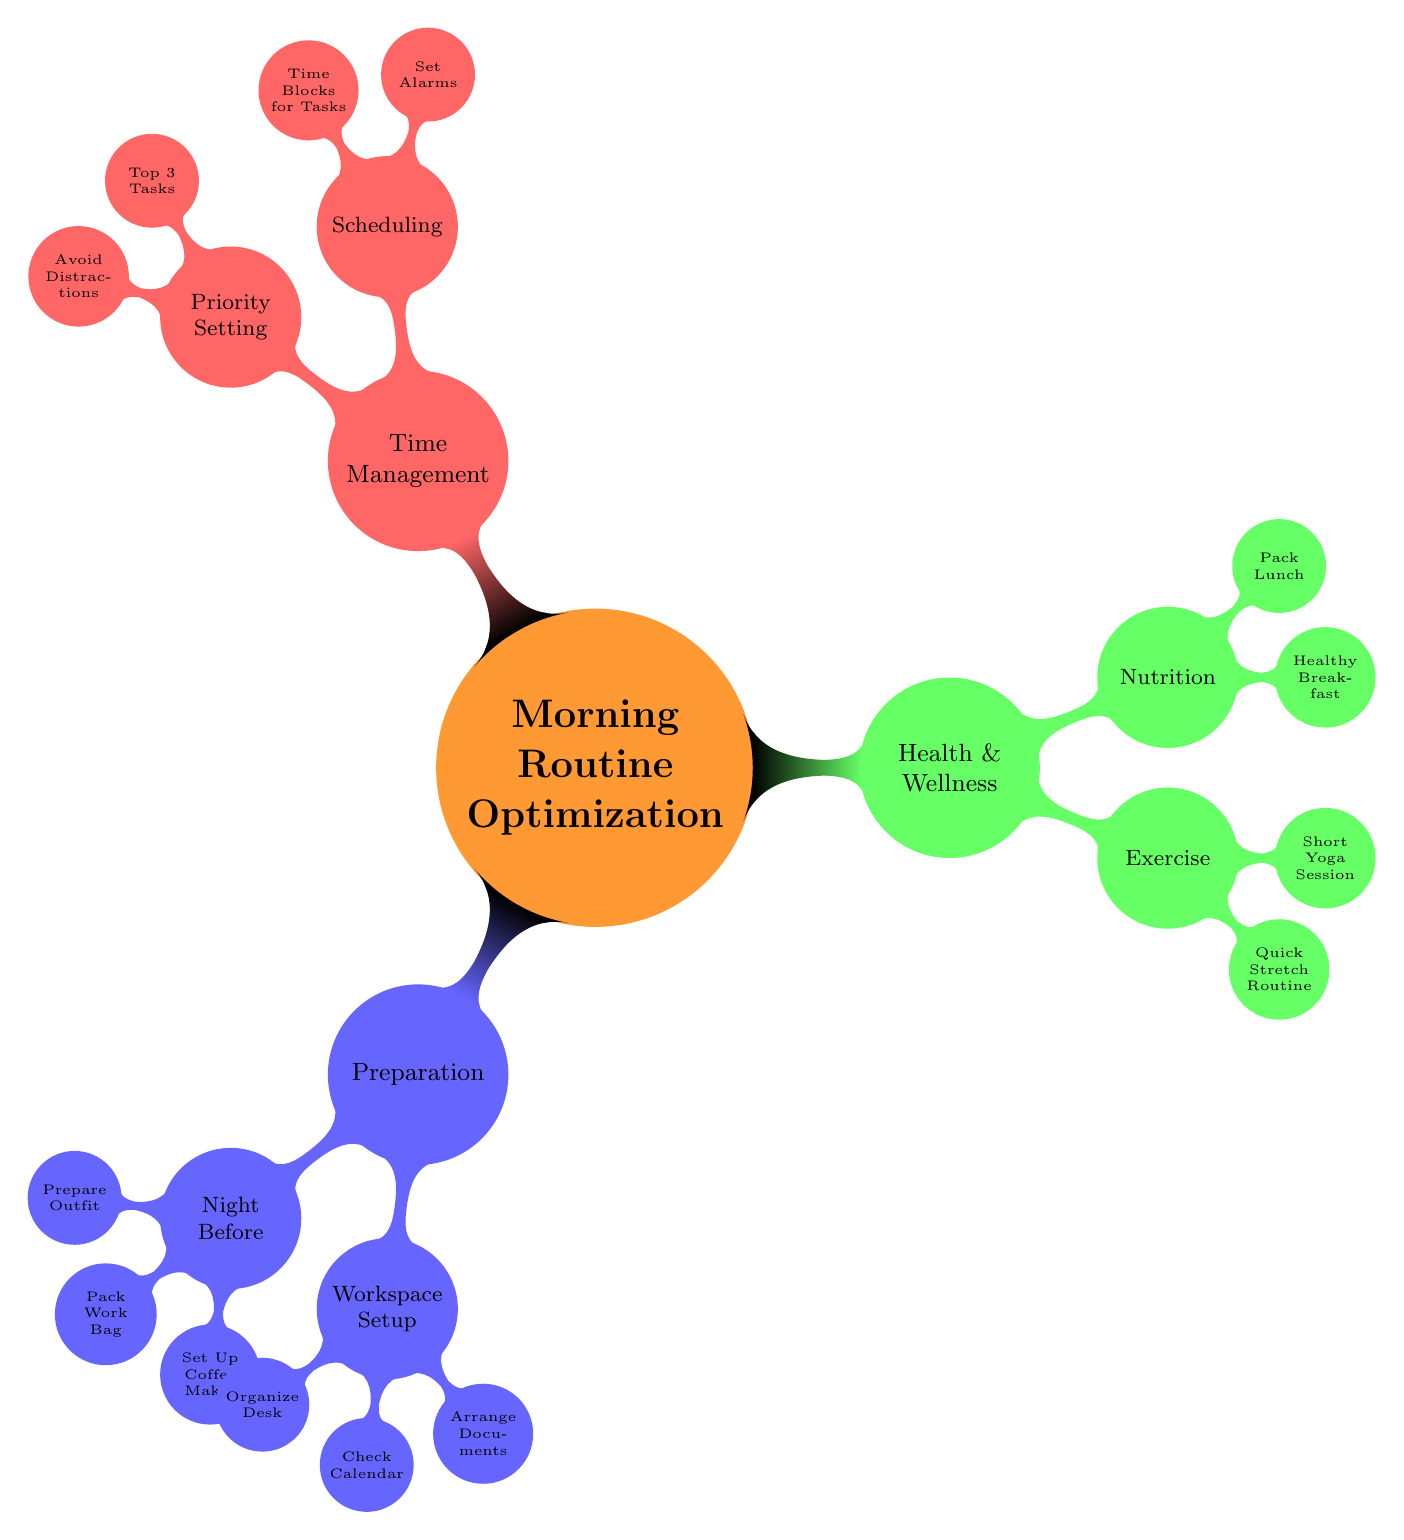What are the three main categories in the diagram? The diagram identifies three main categories under “Morning Routine Optimization”: Preparation, Health & Wellness, and Time Management.
Answer: Preparation, Health & Wellness, Time Management How many subcategories does the "Preparation" category have? Under the "Preparation" category, there are two subcategories: Night Before and Workspace Setup. Counting these gives us 2.
Answer: 2 What is one task under the "Nutrition" subcategory? The Nutrition subcategory lists two tasks, one of which is "Healthy Breakfast." This task can be referenced as part of the Nutrition focus in Health & Wellness.
Answer: Healthy Breakfast What is the relationship between "Top 3 Tasks" and "Time Management"? "Top 3 Tasks" is a part of the "Priority Setting" subcategory which itself is under the "Time Management" category. This shows that setting priorities is a function of managing time effectively.
Answer: Priority Setting How many tasks are associated with "Exercise"? In the "Exercise" subcategory, there are two tasks mentioned: "Quick Stretch Routine" and "Short Yoga Session." So, this totals to 2 associated tasks.
Answer: 2 What is a preparation task done the night before? Among the tasks listed under "Night Before" in the Preparation category, a specific preparation task is "Prepare Outfit." This is one of the tasks aimed at optimizing the morning routine.
Answer: Prepare Outfit What does the "Scheduling" subcategory focus on? The "Scheduling" subcategory under Time Management contains tasks that focus on planning the morning, including "Set Alarms" and "Time Blocks for Tasks." Each of these helps structure the morning efficiently.
Answer: Set Alarms, Time Blocks for Tasks Which subcategory includes "Quick Stretch Routine"? "Quick Stretch Routine" is found in the "Exercise" subcategory located under the "Health & Wellness" category. This highlights its role in physical well-being as part of the morning activities.
Answer: Exercise What is the primary focus of the "Health & Wellness" category? The "Health & Wellness" category is primarily focused on two aspects: Exercise and Nutrition, which aim to ensure the individual is physically ready for the day ahead.
Answer: Exercise, Nutrition 